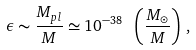Convert formula to latex. <formula><loc_0><loc_0><loc_500><loc_500>\epsilon \sim \frac { M _ { p l } } { M } \simeq 1 0 ^ { - 3 8 } \ \left ( \frac { M _ { \odot } } { M } \right ) \, ,</formula> 